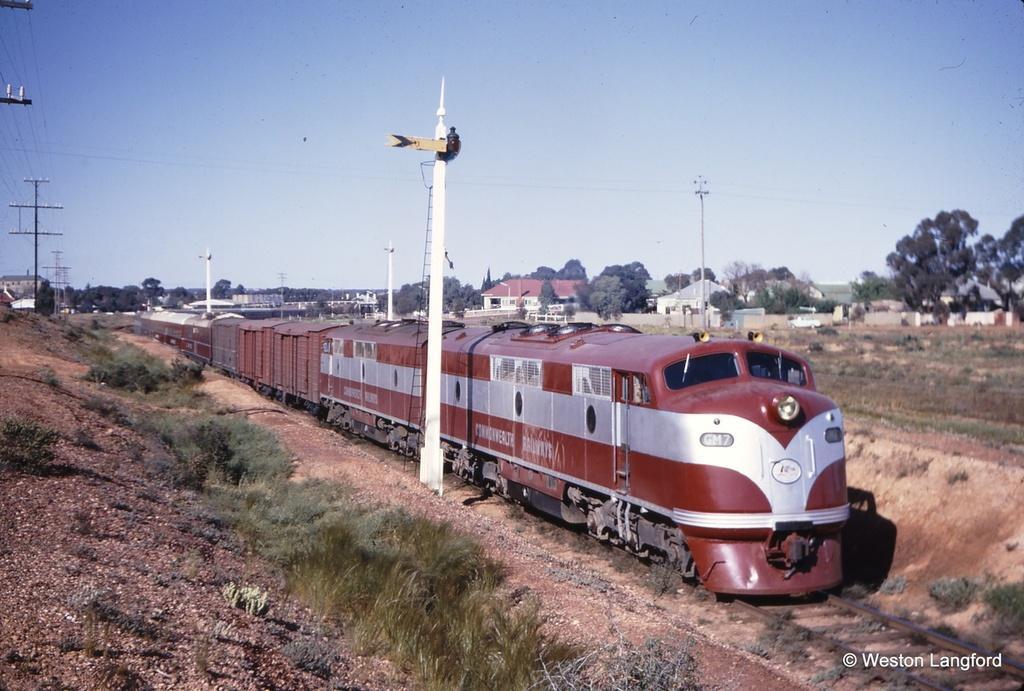Describe this image in one or two sentences. In this picture there is a red color train in the center of the image and there are houses and trees in the background area of the image, there are poles and wires in the image. 